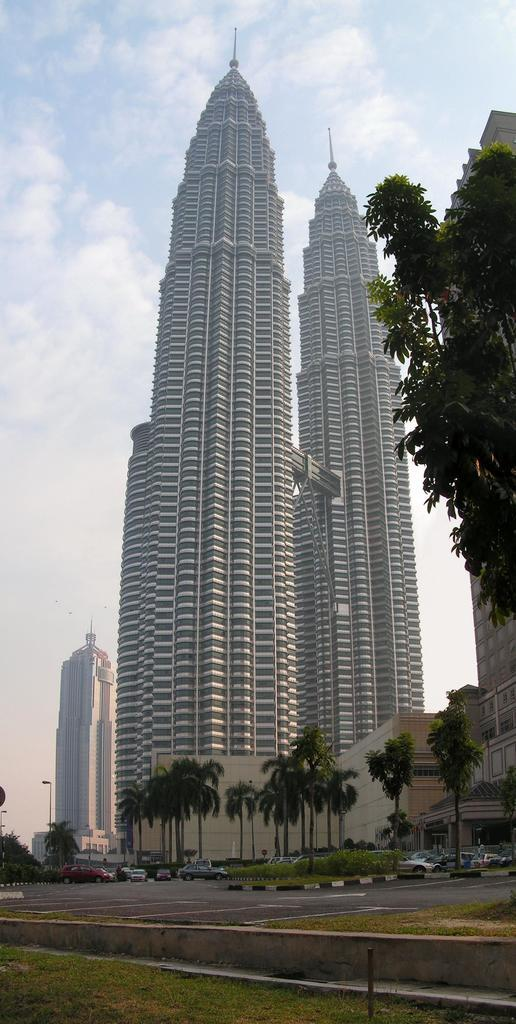What is the main feature of the image? There is a road in the image. What can be seen in the background of the image? There are vehicles visible in the background. What type of vegetation is present in the image? There are trees with green color in the image. What type of structures are visible in the image? There are buildings with white and brown colors in the image. What is the color of the sky in the image? The sky has a combination of white and blue colors in the image. Is there a spy hiding behind the trees in the image? There is no indication of a spy or any hidden figure in the image; it only shows a road, vehicles, trees, buildings, and the sky. 